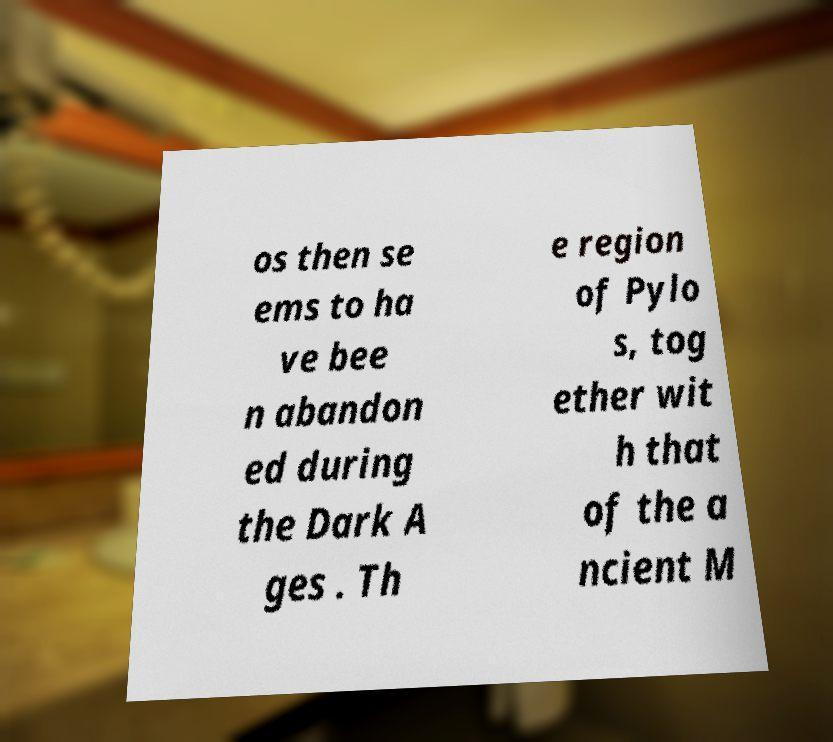Could you extract and type out the text from this image? os then se ems to ha ve bee n abandon ed during the Dark A ges . Th e region of Pylo s, tog ether wit h that of the a ncient M 